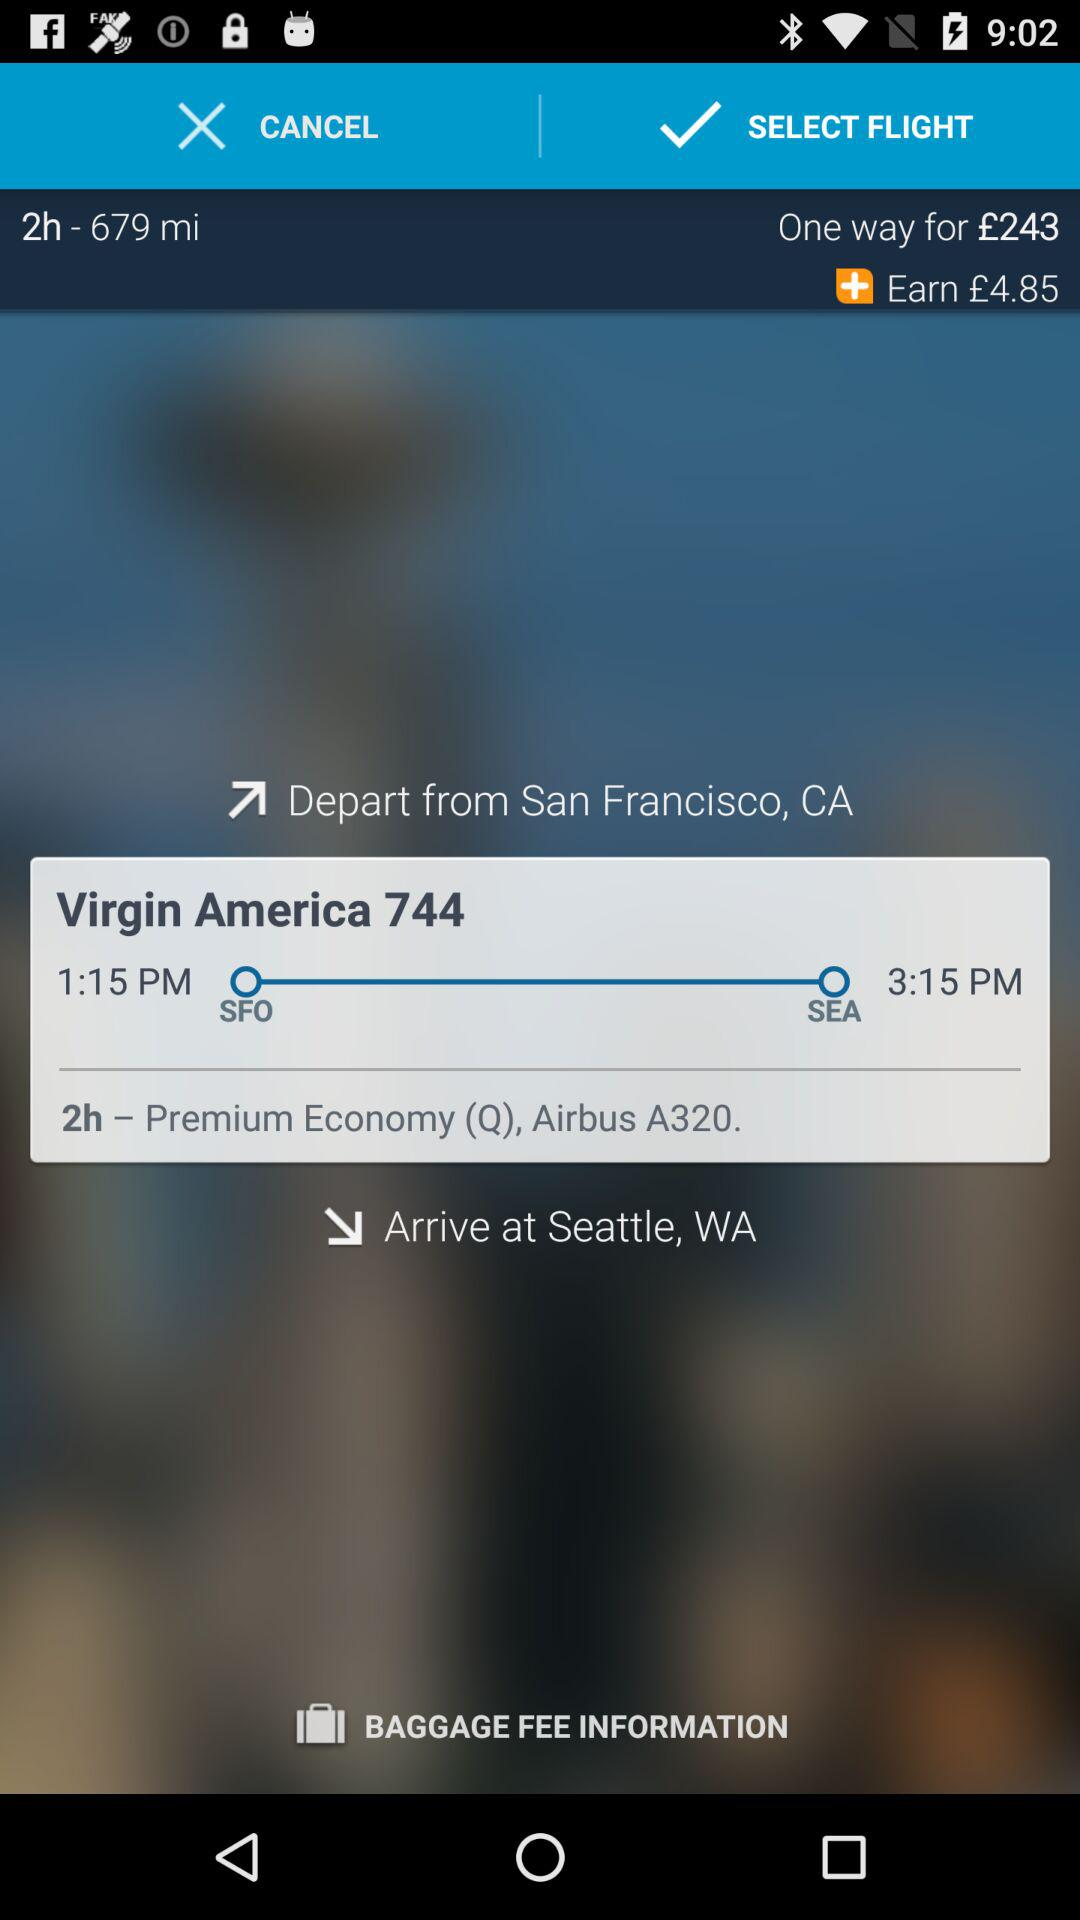What is the departure time of the flight? The flight, Virgin America 744, is scheduled to depart from San Francisco, CA (SFO) at precisely 1:15 PM and is expected to land in Seattle, WA (SEA) at 3:15 PM. The total duration of the journey is 2 hours, covering a distance of 679 miles in Premium Economy class aboard an Airbus A320. 